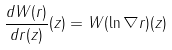<formula> <loc_0><loc_0><loc_500><loc_500>\frac { d W ( r ) } { d r ( z ) } ( z ) = W ( \ln \| \nabla r \| ) ( z )</formula> 